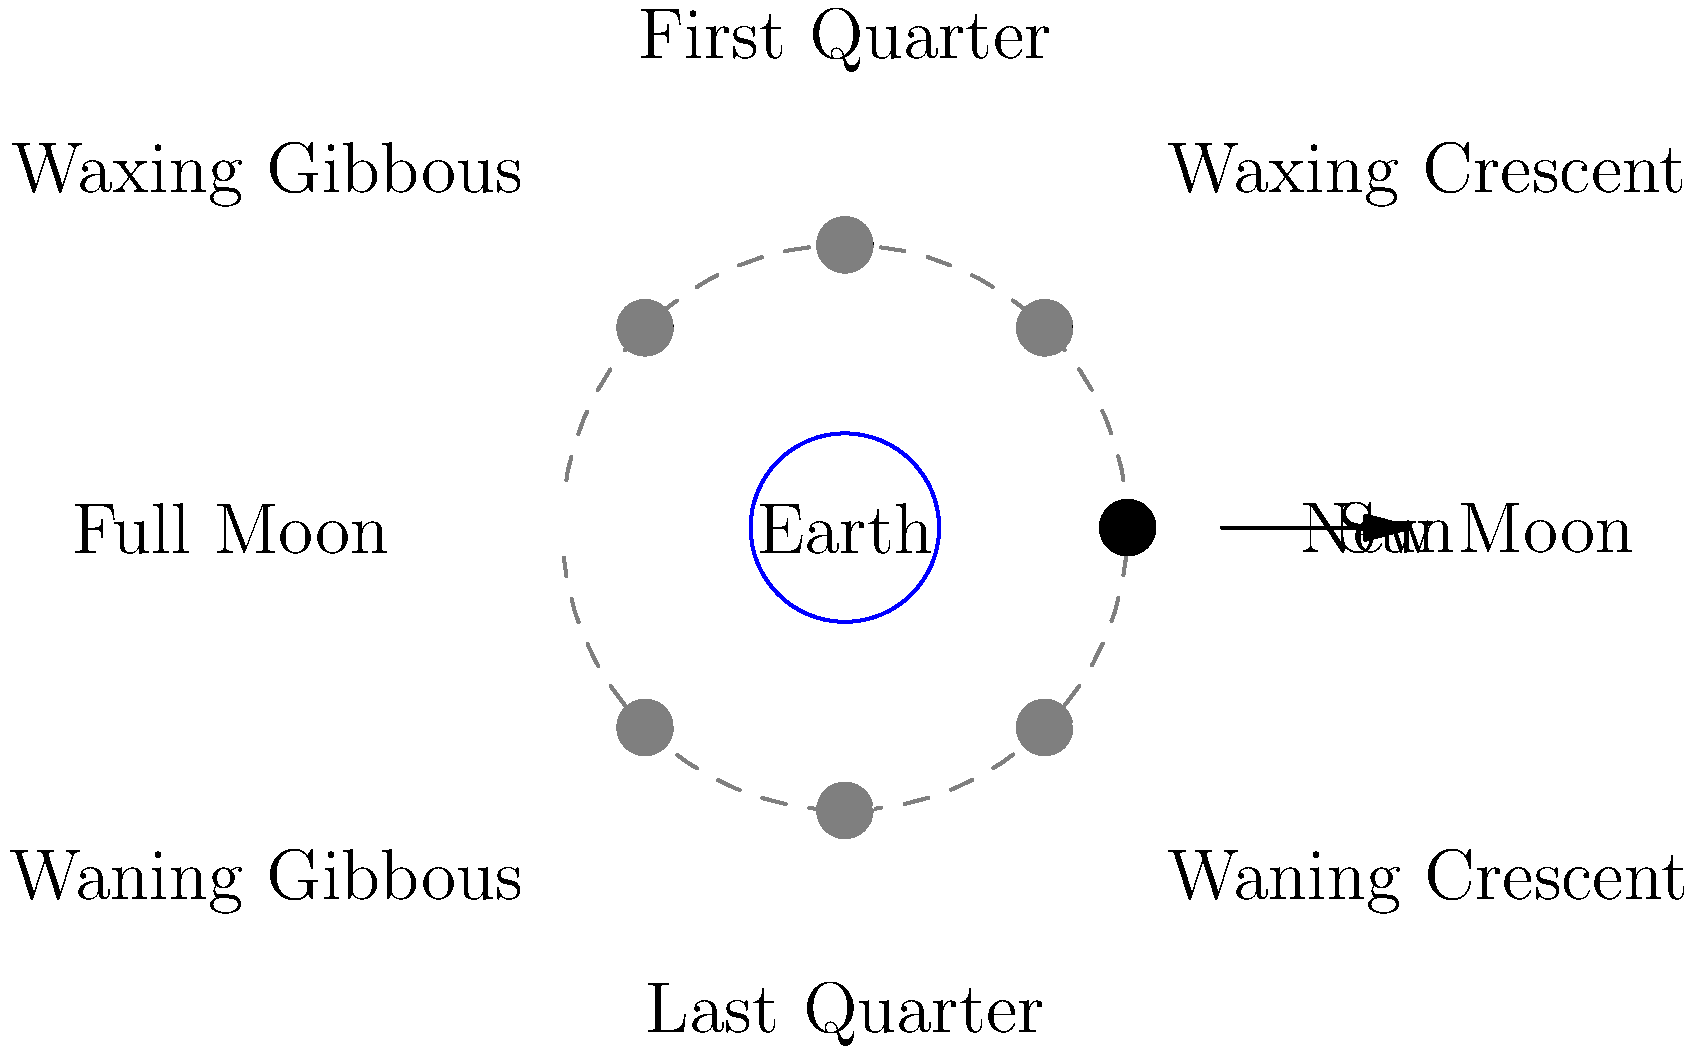In Korean literature, the Moon often symbolizes various emotions and states of being. As you discuss books that feature lunar imagery, which phase of the Moon would best represent a character experiencing gradual revelation or increasing understanding, and why? To answer this question, we need to understand the phases of the Moon and their symbolic meanings:

1. New Moon: Invisible from Earth, symbolizes new beginnings or hidden knowledge.
2. Waxing Crescent: A sliver of light appears, representing hope and growth.
3. First Quarter: Half of the Moon is illuminated, signifying decision-making and action.
4. Waxing Gibbous: Most of the Moon is visible, symbolizing refinement and preparation.
5. Full Moon: Completely illuminated, representing completion, clarity, and revelation.
6. Waning Gibbous: Light begins to decrease, symbolizing reflection and sharing.
7. Last Quarter: Half of the Moon is dark, representing release and letting go.
8. Waning Crescent: Only a sliver remains visible, symbolizing surrender and rest.

For a character experiencing gradual revelation or increasing understanding, the Waxing Crescent to Waxing Gibbous phases would be most appropriate. These phases show the Moon gradually becoming more illuminated, which parallels the character's journey of discovery.

The Waxing Crescent phase, in particular, represents the initial stages of growth and understanding. As the crescent grows into a Waxing Gibbous, it symbolizes the character gaining more knowledge and insight, leading to a fuller understanding.

This gradual increase in illumination mirrors the process of learning and discovery, making it an excellent metaphor for a character's journey towards greater understanding in Korean literature.
Answer: Waxing Crescent to Waxing Gibbous 